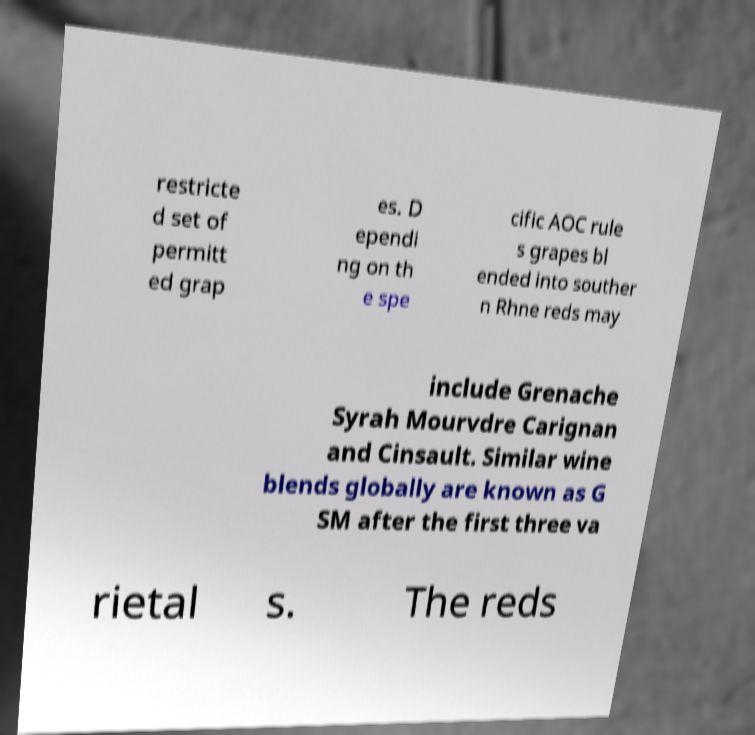Can you read and provide the text displayed in the image?This photo seems to have some interesting text. Can you extract and type it out for me? restricte d set of permitt ed grap es. D ependi ng on th e spe cific AOC rule s grapes bl ended into souther n Rhne reds may include Grenache Syrah Mourvdre Carignan and Cinsault. Similar wine blends globally are known as G SM after the first three va rietal s. The reds 